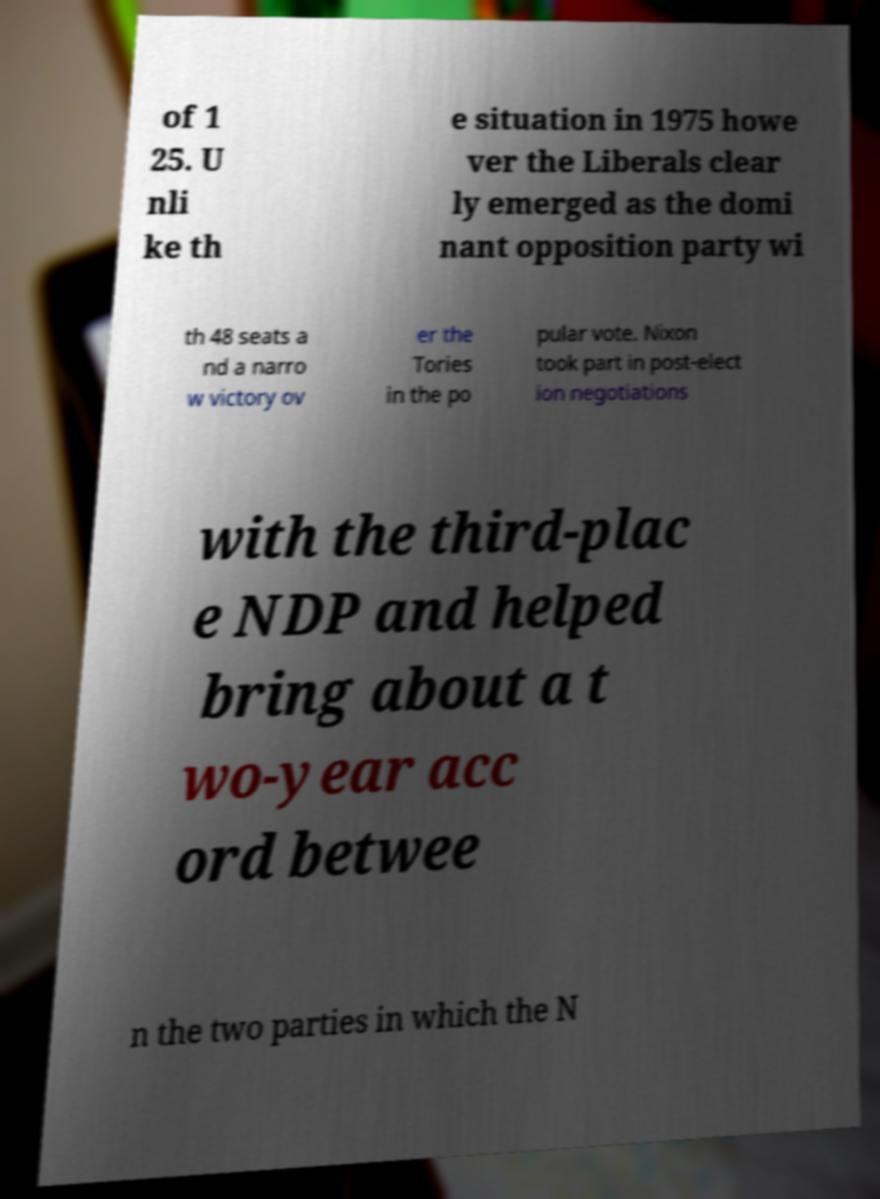Can you accurately transcribe the text from the provided image for me? of 1 25. U nli ke th e situation in 1975 howe ver the Liberals clear ly emerged as the domi nant opposition party wi th 48 seats a nd a narro w victory ov er the Tories in the po pular vote. Nixon took part in post-elect ion negotiations with the third-plac e NDP and helped bring about a t wo-year acc ord betwee n the two parties in which the N 